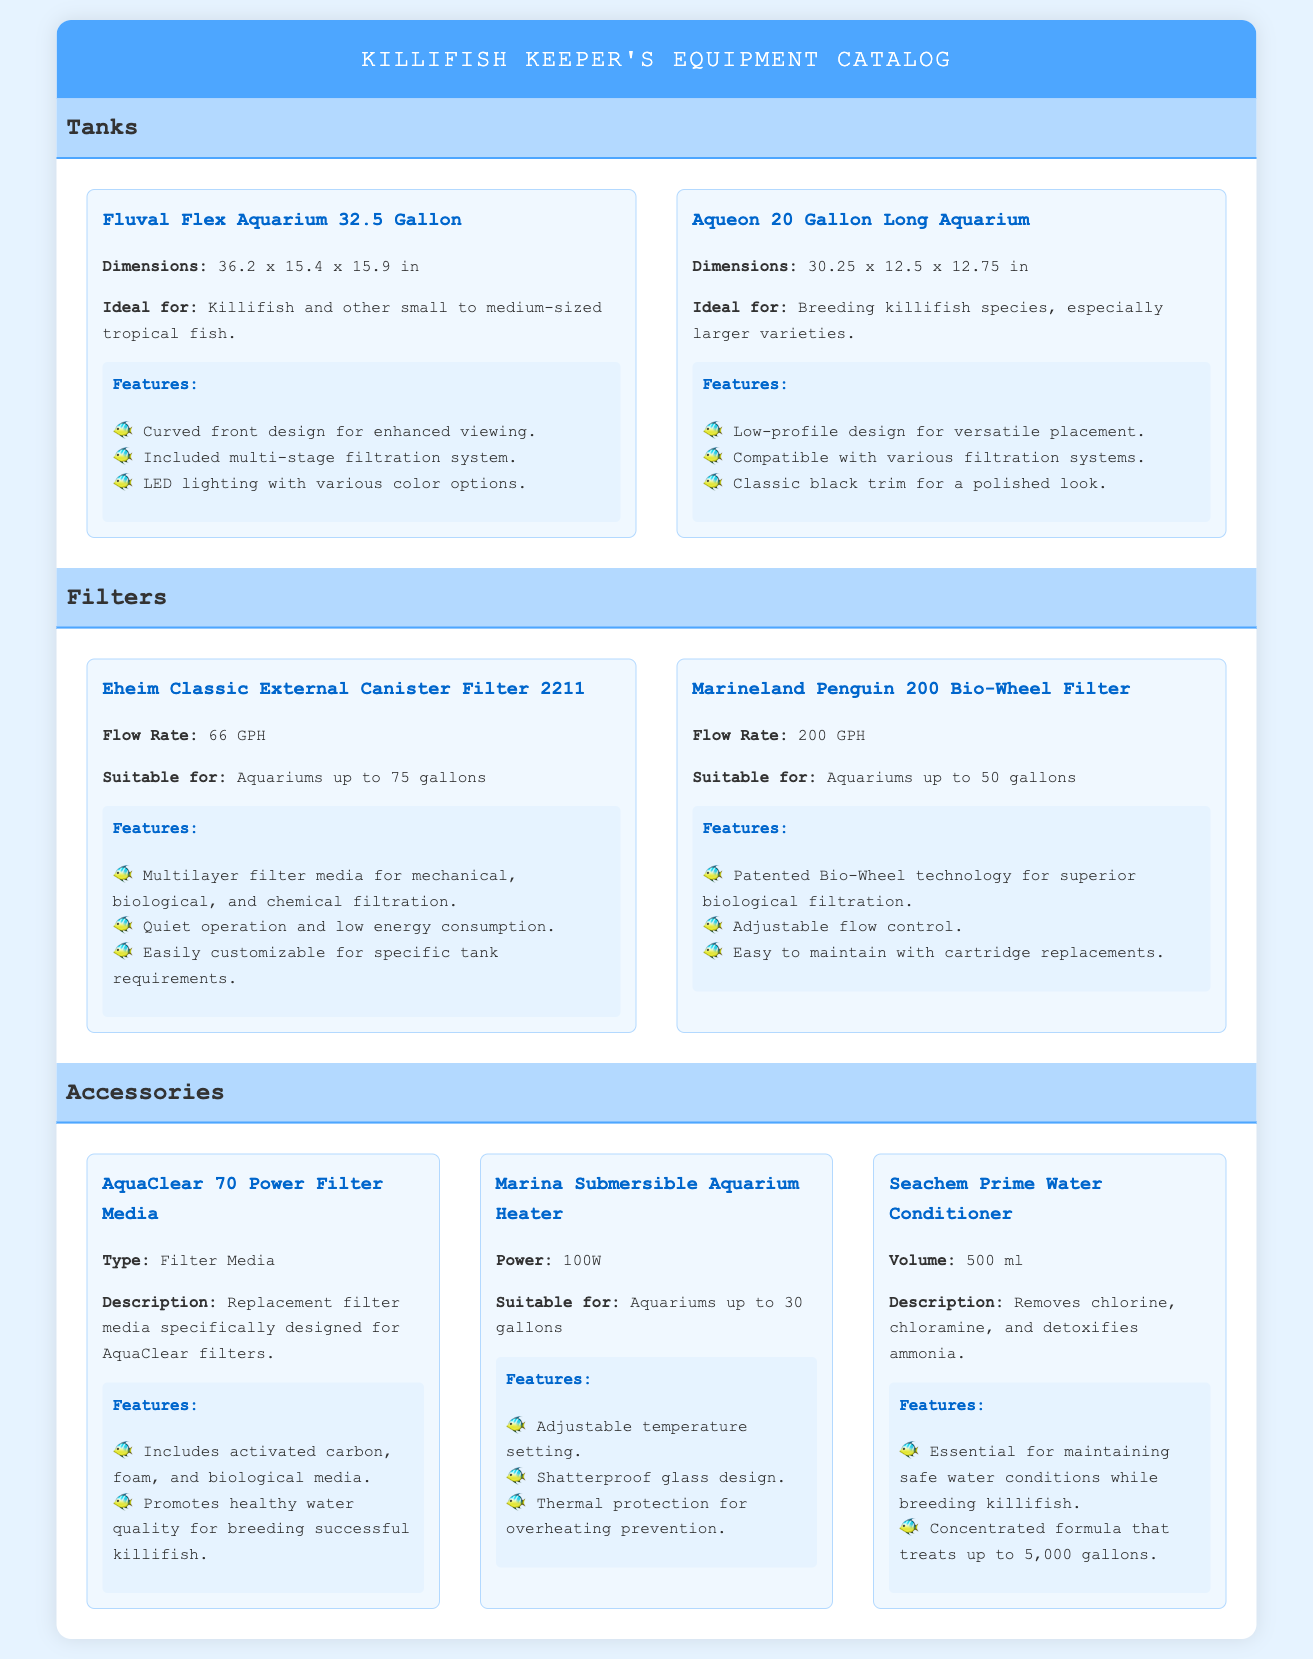What is the volume of the Fluval Flex Aquarium? The volume of the Fluval Flex Aquarium is explicitly stated in the document as 32.5 gallons.
Answer: 32.5 gallons What is the flow rate of the Marineland Penguin 200 Bio-Wheel Filter? The flow rate is a specific piece of information given for the filter, which is 200 GPH.
Answer: 200 GPH Which tank is ideal for breeding larger killifish species? The ideal tank for breeding larger killifish species is the Aqueon 20 Gallon Long Aquarium, as mentioned in the document.
Answer: Aqueon 20 Gallon Long Aquarium How many gallons can the Eheim Classic External Canister Filter support? The document states that the Eheim Classic External Canister Filter is suitable for aquariums up to 75 gallons.
Answer: 75 gallons What type of filter media is included in the AquaClear 70 Power Filter Media? This refers to the specific components of the filter media, which include activated carbon, foam, and biological media as noted in the document.
Answer: Activated carbon, foam, and biological media Which accessory is essential for maintaining safe water conditions while breeding killifish? The document specifies that Seachem Prime Water Conditioner is essential for maintaining safe water conditions.
Answer: Seachem Prime Water Conditioner What is the power rating of the Marina Submersible Aquarium Heater? The power rating of the heater is mentioned in the document as 100W.
Answer: 100W What design feature does the Fluval Flex Aquarium have? The document notes that the Fluval Flex Aquarium has a curved front design for enhanced viewing.
Answer: Curved front design 